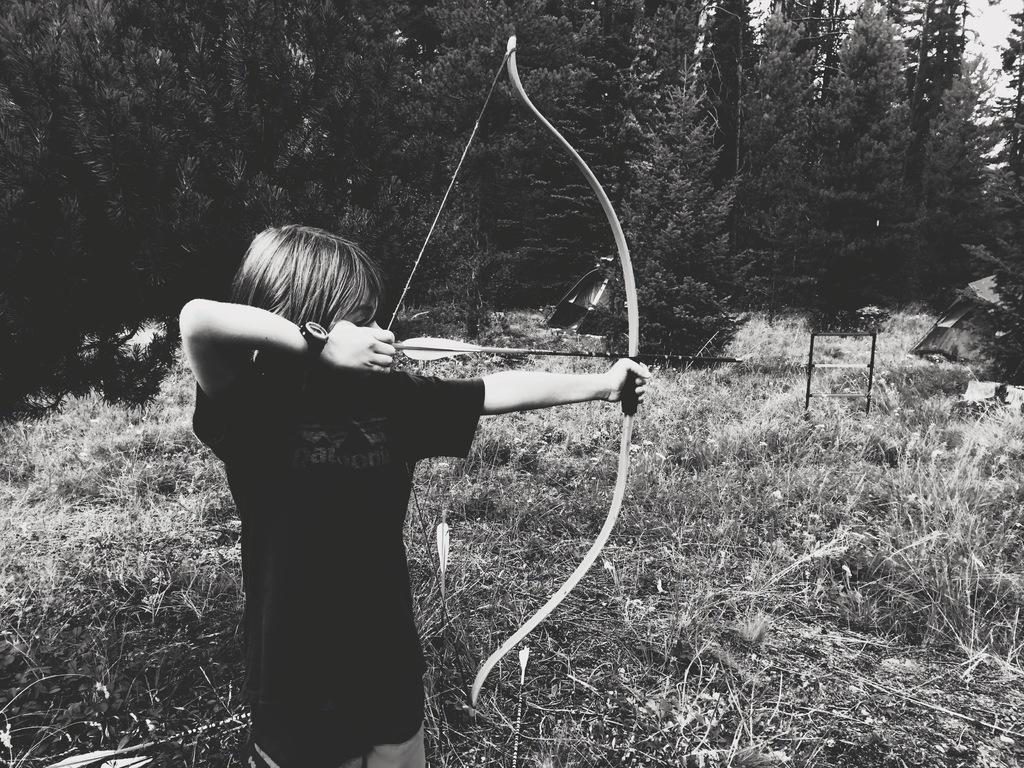Can you describe this image briefly? In this image I can see a boy is holding an arrow in hand and grass. In the background I can see trees. On the top right I can see the sky. This image is taken may be in the forest. 